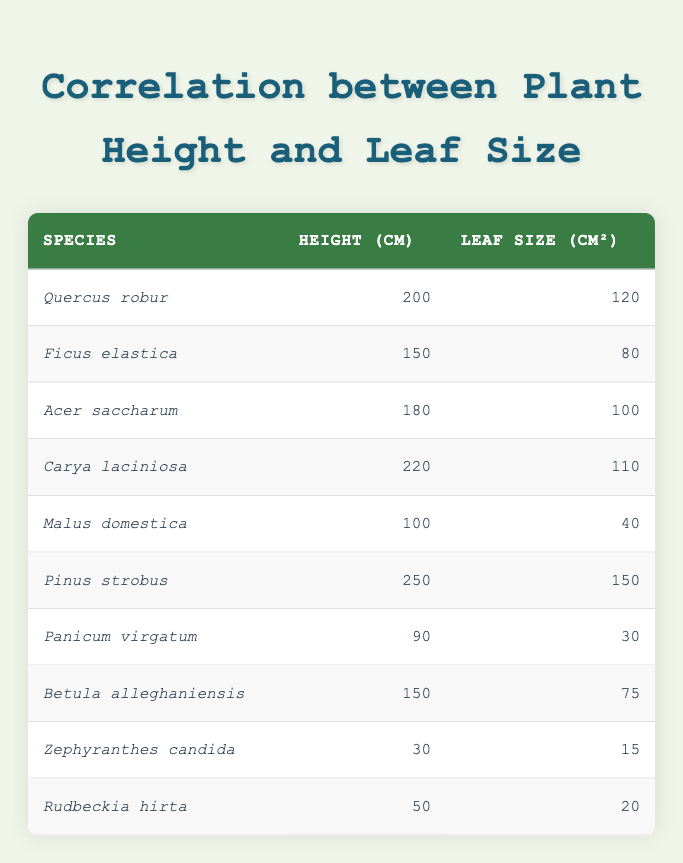What is the height of Quercus robur? Referring directly to the table, the row for Quercus robur indicates that its height is listed as 200 cm.
Answer: 200 cm Which species has the largest leaf size? Looking through the leaf size values in the table, Pinus strobus has the largest value at 150 cm².
Answer: Pinus strobus What is the difference in height between the tallest plant and the shortest plant? The tallest plant is Pinus strobus at 250 cm and the shortest plant is Zephyranthes candida at 30 cm. The difference can be calculated as 250 cm - 30 cm = 220 cm.
Answer: 220 cm Is Malus domestica taller than Panicum virgatum? Comparing the heights, Malus domestica is 100 cm and Panicum virgatum is 90 cm. Since 100 cm is greater than 90 cm, the statement is true.
Answer: Yes What is the average leaf size of the plants listed? First, we sum the leaf sizes: 120 + 80 + 100 + 110 + 40 + 150 + 30 + 75 + 15 + 20 = 720 cm². There are 10 species, so we find the average by dividing: 720 cm² / 10 = 72 cm².
Answer: 72 cm² Which plant species has the closest leaf size to 100 cm²? Looking at the leaf sizes, Acer saccharum has a leaf size of 100 cm², which matches exactly. No other species is closer.
Answer: Acer saccharum How many species have a leaf size greater than 80 cm²? By examining the leaf sizes, the species with leaf sizes greater than 80 cm² are Quercus robur (120), Ficus elastica (80), Acer saccharum (100), Carya laciniosa (110), and Pinus strobus (150). This totals 5 species.
Answer: 5 species If you combine the heights of Ficus elastica and Betula alleghaniensis, what is the total height? The height of Ficus elastica is 150 cm, and the height of Betula alleghaniensis is also 150 cm. By adding these together: 150 cm + 150 cm = 300 cm.
Answer: 300 cm Which species has a higher height, Carya laciniosa or Malus domestica? Carya laciniosa has a height of 220 cm, while Malus domestica is only 100 cm. Thus, Carya laciniosa is taller.
Answer: Carya laciniosa 